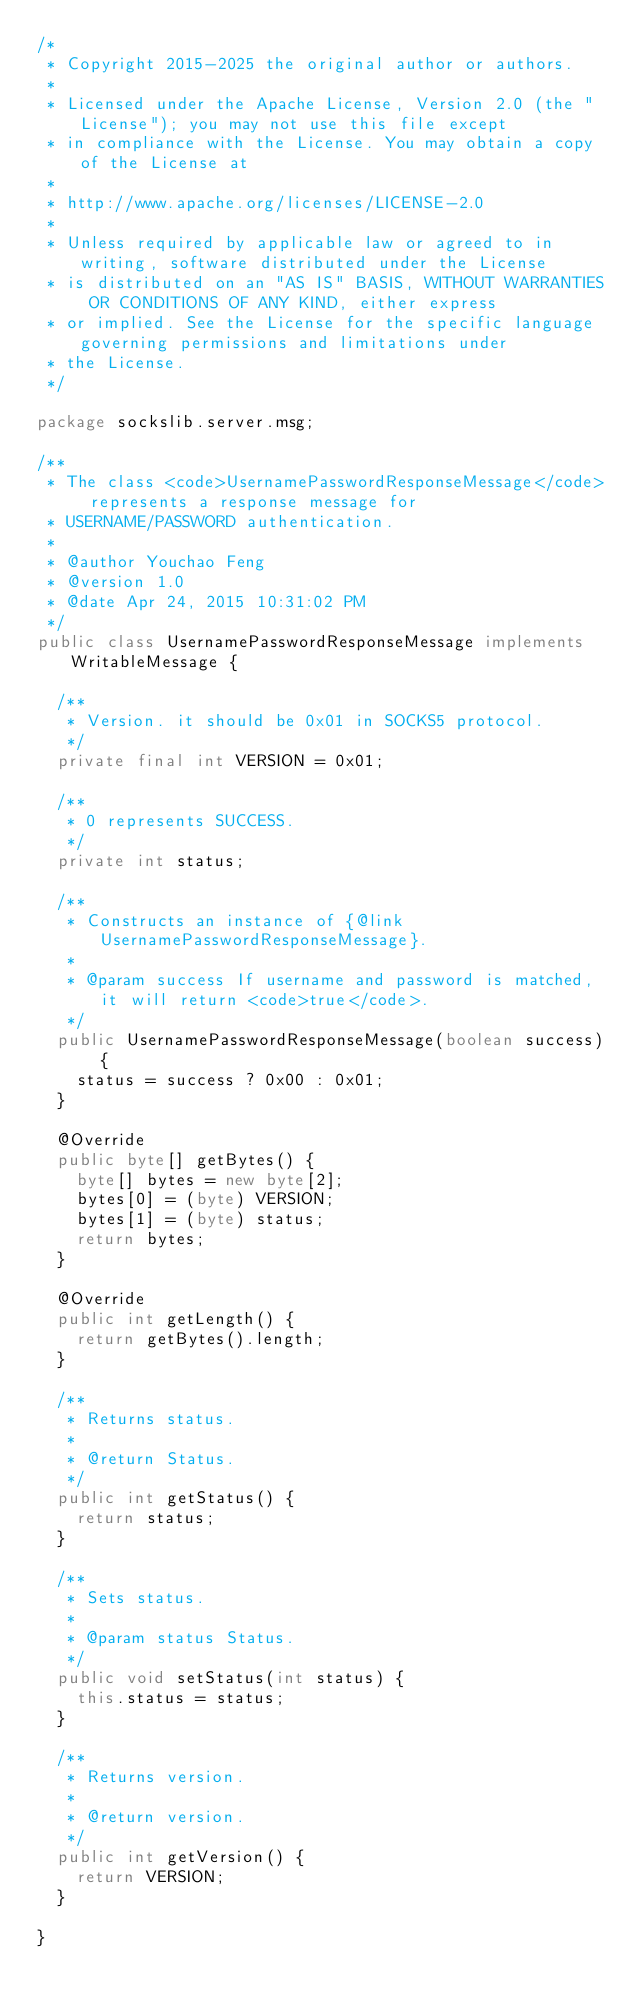Convert code to text. <code><loc_0><loc_0><loc_500><loc_500><_Java_>/*
 * Copyright 2015-2025 the original author or authors.
 * 
 * Licensed under the Apache License, Version 2.0 (the "License"); you may not use this file except
 * in compliance with the License. You may obtain a copy of the License at
 * 
 * http://www.apache.org/licenses/LICENSE-2.0
 * 
 * Unless required by applicable law or agreed to in writing, software distributed under the License
 * is distributed on an "AS IS" BASIS, WITHOUT WARRANTIES OR CONDITIONS OF ANY KIND, either express
 * or implied. See the License for the specific language governing permissions and limitations under
 * the License.
 */

package sockslib.server.msg;

/**
 * The class <code>UsernamePasswordResponseMessage</code> represents a response message for
 * USERNAME/PASSWORD authentication.
 *
 * @author Youchao Feng
 * @version 1.0
 * @date Apr 24, 2015 10:31:02 PM
 */
public class UsernamePasswordResponseMessage implements WritableMessage {

  /**
   * Version. it should be 0x01 in SOCKS5 protocol.
   */
  private final int VERSION = 0x01;

  /**
   * 0 represents SUCCESS.
   */
  private int status;

  /**
   * Constructs an instance of {@link UsernamePasswordResponseMessage}.
   *
   * @param success If username and password is matched, it will return <code>true</code>.
   */
  public UsernamePasswordResponseMessage(boolean success) {
    status = success ? 0x00 : 0x01;
  }

  @Override
  public byte[] getBytes() {
    byte[] bytes = new byte[2];
    bytes[0] = (byte) VERSION;
    bytes[1] = (byte) status;
    return bytes;
  }

  @Override
  public int getLength() {
    return getBytes().length;
  }

  /**
   * Returns status.
   *
   * @return Status.
   */
  public int getStatus() {
    return status;
  }

  /**
   * Sets status.
   *
   * @param status Status.
   */
  public void setStatus(int status) {
    this.status = status;
  }

  /**
   * Returns version.
   *
   * @return version.
   */
  public int getVersion() {
    return VERSION;
  }

}
</code> 